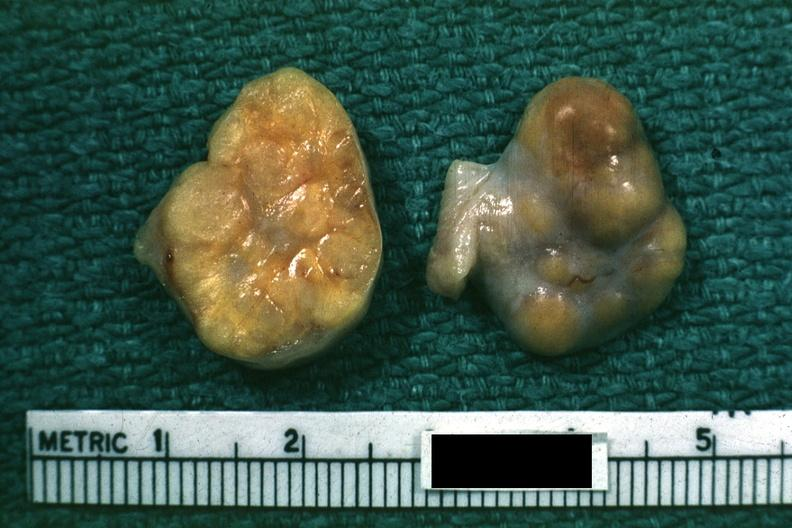how does yellow color indicate theca cells can not recognize as?
Answer the question using a single word or phrase. Ovary 